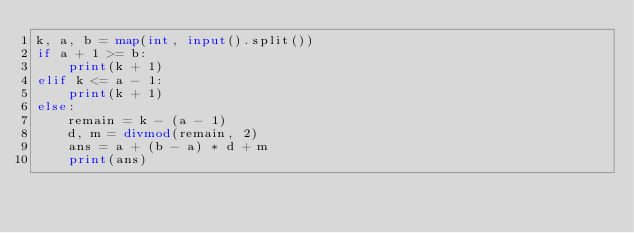<code> <loc_0><loc_0><loc_500><loc_500><_Python_>k, a, b = map(int, input().split())
if a + 1 >= b:
    print(k + 1)
elif k <= a - 1:
    print(k + 1)
else:
    remain = k - (a - 1)
    d, m = divmod(remain, 2)
    ans = a + (b - a) * d + m
    print(ans)
</code> 